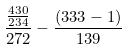<formula> <loc_0><loc_0><loc_500><loc_500>\frac { \frac { 4 3 0 } { 2 3 4 } } { 2 7 2 } - \frac { ( 3 3 3 - 1 ) } { 1 3 9 }</formula> 